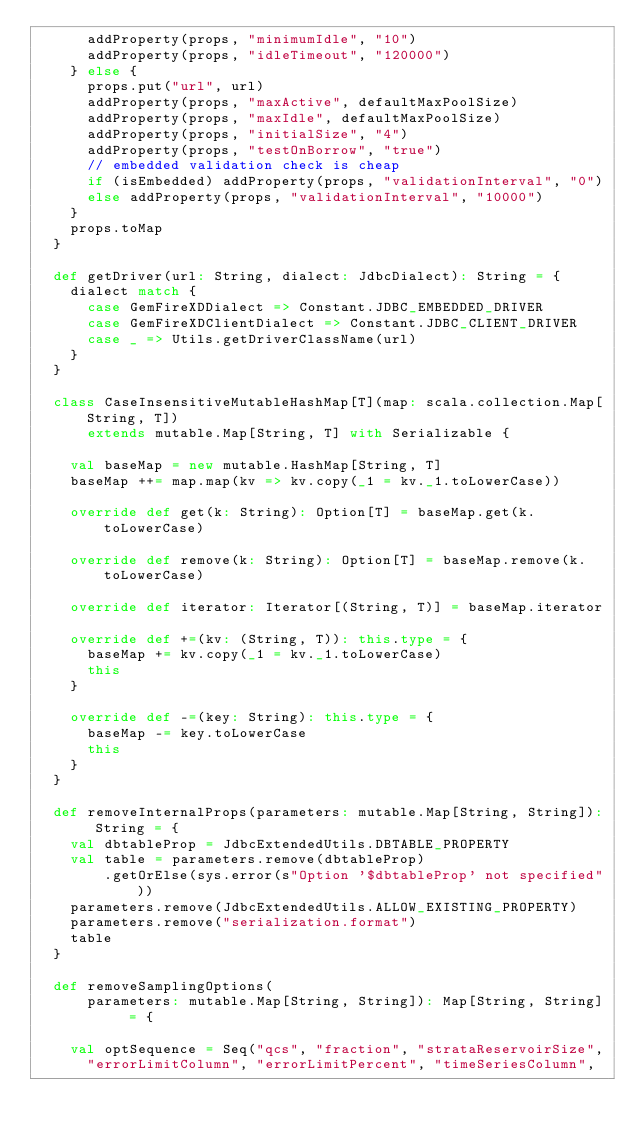Convert code to text. <code><loc_0><loc_0><loc_500><loc_500><_Scala_>      addProperty(props, "minimumIdle", "10")
      addProperty(props, "idleTimeout", "120000")
    } else {
      props.put("url", url)
      addProperty(props, "maxActive", defaultMaxPoolSize)
      addProperty(props, "maxIdle", defaultMaxPoolSize)
      addProperty(props, "initialSize", "4")
      addProperty(props, "testOnBorrow", "true")
      // embedded validation check is cheap
      if (isEmbedded) addProperty(props, "validationInterval", "0")
      else addProperty(props, "validationInterval", "10000")
    }
    props.toMap
  }

  def getDriver(url: String, dialect: JdbcDialect): String = {
    dialect match {
      case GemFireXDDialect => Constant.JDBC_EMBEDDED_DRIVER
      case GemFireXDClientDialect => Constant.JDBC_CLIENT_DRIVER
      case _ => Utils.getDriverClassName(url)
    }
  }

  class CaseInsensitiveMutableHashMap[T](map: scala.collection.Map[String, T])
      extends mutable.Map[String, T] with Serializable {

    val baseMap = new mutable.HashMap[String, T]
    baseMap ++= map.map(kv => kv.copy(_1 = kv._1.toLowerCase))

    override def get(k: String): Option[T] = baseMap.get(k.toLowerCase)

    override def remove(k: String): Option[T] = baseMap.remove(k.toLowerCase)

    override def iterator: Iterator[(String, T)] = baseMap.iterator

    override def +=(kv: (String, T)): this.type = {
      baseMap += kv.copy(_1 = kv._1.toLowerCase)
      this
    }

    override def -=(key: String): this.type = {
      baseMap -= key.toLowerCase
      this
    }
  }

  def removeInternalProps(parameters: mutable.Map[String, String]): String = {
    val dbtableProp = JdbcExtendedUtils.DBTABLE_PROPERTY
    val table = parameters.remove(dbtableProp)
        .getOrElse(sys.error(s"Option '$dbtableProp' not specified"))
    parameters.remove(JdbcExtendedUtils.ALLOW_EXISTING_PROPERTY)
    parameters.remove("serialization.format")
    table
  }

  def removeSamplingOptions(
      parameters: mutable.Map[String, String]): Map[String, String] = {

    val optSequence = Seq("qcs", "fraction", "strataReservoirSize",
      "errorLimitColumn", "errorLimitPercent", "timeSeriesColumn",</code> 